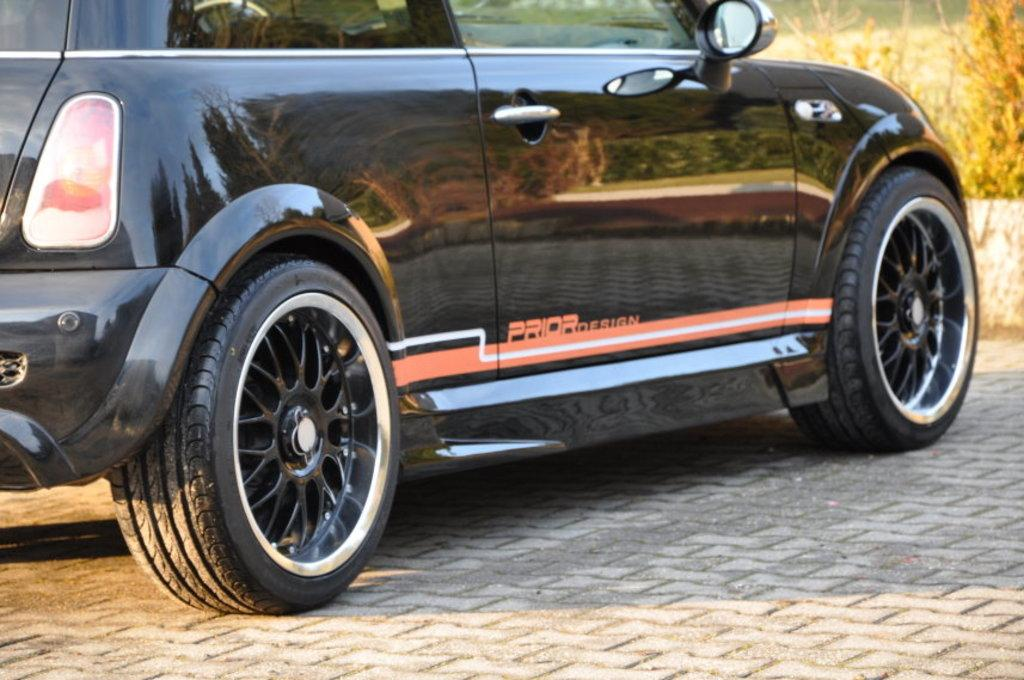What is the main subject of the image? There is a vehicle in the image. What color is the vehicle? The vehicle is black in color. What can be seen in the background of the image? There are plants in the background of the image. What color are the plants? The plants are green in color. What is the name of the person driving the vehicle in the image? There is no person visible in the image, so it is not possible to determine the name of the driver. 